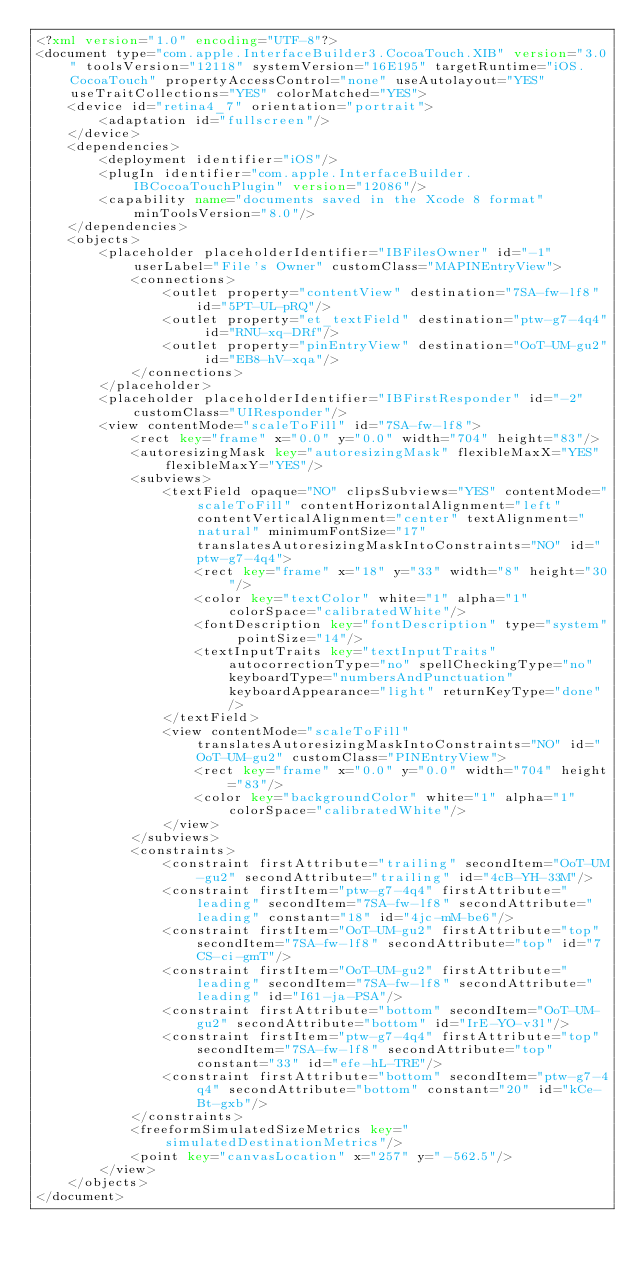Convert code to text. <code><loc_0><loc_0><loc_500><loc_500><_XML_><?xml version="1.0" encoding="UTF-8"?>
<document type="com.apple.InterfaceBuilder3.CocoaTouch.XIB" version="3.0" toolsVersion="12118" systemVersion="16E195" targetRuntime="iOS.CocoaTouch" propertyAccessControl="none" useAutolayout="YES" useTraitCollections="YES" colorMatched="YES">
    <device id="retina4_7" orientation="portrait">
        <adaptation id="fullscreen"/>
    </device>
    <dependencies>
        <deployment identifier="iOS"/>
        <plugIn identifier="com.apple.InterfaceBuilder.IBCocoaTouchPlugin" version="12086"/>
        <capability name="documents saved in the Xcode 8 format" minToolsVersion="8.0"/>
    </dependencies>
    <objects>
        <placeholder placeholderIdentifier="IBFilesOwner" id="-1" userLabel="File's Owner" customClass="MAPINEntryView">
            <connections>
                <outlet property="contentView" destination="7SA-fw-lf8" id="5PT-UL-pRQ"/>
                <outlet property="et_textField" destination="ptw-g7-4q4" id="RNU-xq-DRf"/>
                <outlet property="pinEntryView" destination="OoT-UM-gu2" id="EB8-hV-xqa"/>
            </connections>
        </placeholder>
        <placeholder placeholderIdentifier="IBFirstResponder" id="-2" customClass="UIResponder"/>
        <view contentMode="scaleToFill" id="7SA-fw-lf8">
            <rect key="frame" x="0.0" y="0.0" width="704" height="83"/>
            <autoresizingMask key="autoresizingMask" flexibleMaxX="YES" flexibleMaxY="YES"/>
            <subviews>
                <textField opaque="NO" clipsSubviews="YES" contentMode="scaleToFill" contentHorizontalAlignment="left" contentVerticalAlignment="center" textAlignment="natural" minimumFontSize="17" translatesAutoresizingMaskIntoConstraints="NO" id="ptw-g7-4q4">
                    <rect key="frame" x="18" y="33" width="8" height="30"/>
                    <color key="textColor" white="1" alpha="1" colorSpace="calibratedWhite"/>
                    <fontDescription key="fontDescription" type="system" pointSize="14"/>
                    <textInputTraits key="textInputTraits" autocorrectionType="no" spellCheckingType="no" keyboardType="numbersAndPunctuation" keyboardAppearance="light" returnKeyType="done"/>
                </textField>
                <view contentMode="scaleToFill" translatesAutoresizingMaskIntoConstraints="NO" id="OoT-UM-gu2" customClass="PINEntryView">
                    <rect key="frame" x="0.0" y="0.0" width="704" height="83"/>
                    <color key="backgroundColor" white="1" alpha="1" colorSpace="calibratedWhite"/>
                </view>
            </subviews>
            <constraints>
                <constraint firstAttribute="trailing" secondItem="OoT-UM-gu2" secondAttribute="trailing" id="4cB-YH-33M"/>
                <constraint firstItem="ptw-g7-4q4" firstAttribute="leading" secondItem="7SA-fw-lf8" secondAttribute="leading" constant="18" id="4jc-mM-be6"/>
                <constraint firstItem="OoT-UM-gu2" firstAttribute="top" secondItem="7SA-fw-lf8" secondAttribute="top" id="7CS-ci-gmT"/>
                <constraint firstItem="OoT-UM-gu2" firstAttribute="leading" secondItem="7SA-fw-lf8" secondAttribute="leading" id="I61-ja-PSA"/>
                <constraint firstAttribute="bottom" secondItem="OoT-UM-gu2" secondAttribute="bottom" id="IrE-YO-v3l"/>
                <constraint firstItem="ptw-g7-4q4" firstAttribute="top" secondItem="7SA-fw-lf8" secondAttribute="top" constant="33" id="efe-hL-TRE"/>
                <constraint firstAttribute="bottom" secondItem="ptw-g7-4q4" secondAttribute="bottom" constant="20" id="kCe-Bt-gxb"/>
            </constraints>
            <freeformSimulatedSizeMetrics key="simulatedDestinationMetrics"/>
            <point key="canvasLocation" x="257" y="-562.5"/>
        </view>
    </objects>
</document>
</code> 